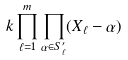<formula> <loc_0><loc_0><loc_500><loc_500>k \prod _ { \ell = 1 } ^ { m } \prod _ { \alpha \in S _ { \ell } ^ { \prime } } ( X _ { \ell } - \alpha )</formula> 